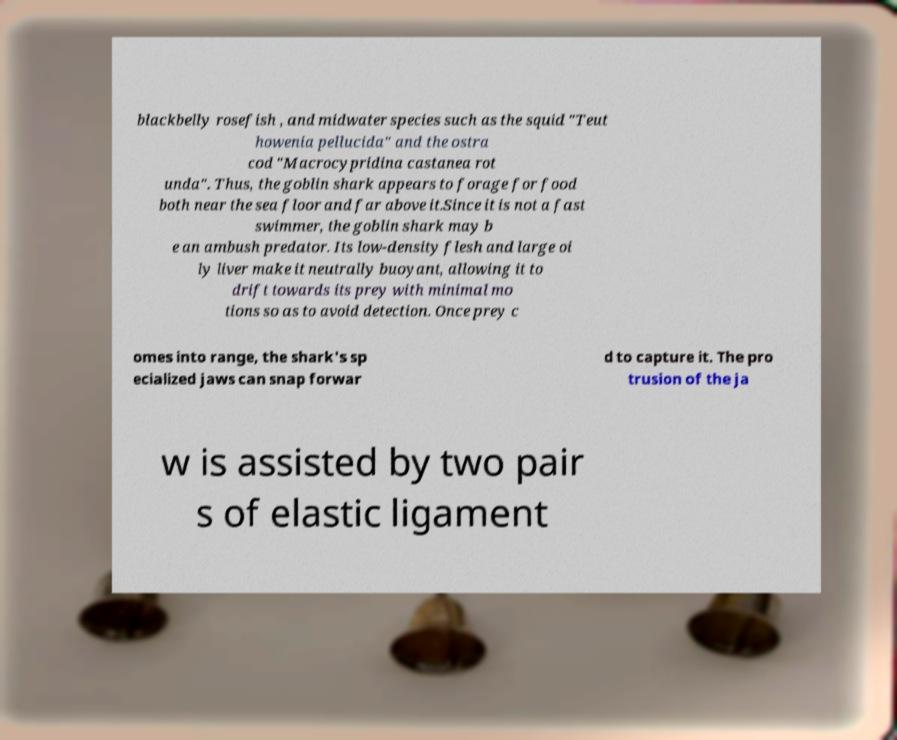Can you accurately transcribe the text from the provided image for me? blackbelly rosefish , and midwater species such as the squid "Teut howenia pellucida" and the ostra cod "Macrocypridina castanea rot unda". Thus, the goblin shark appears to forage for food both near the sea floor and far above it.Since it is not a fast swimmer, the goblin shark may b e an ambush predator. Its low-density flesh and large oi ly liver make it neutrally buoyant, allowing it to drift towards its prey with minimal mo tions so as to avoid detection. Once prey c omes into range, the shark's sp ecialized jaws can snap forwar d to capture it. The pro trusion of the ja w is assisted by two pair s of elastic ligament 